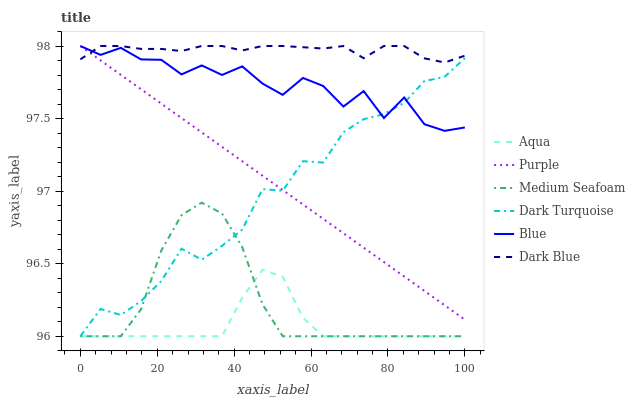Does Purple have the minimum area under the curve?
Answer yes or no. No. Does Purple have the maximum area under the curve?
Answer yes or no. No. Is Dark Turquoise the smoothest?
Answer yes or no. No. Is Dark Turquoise the roughest?
Answer yes or no. No. Does Purple have the lowest value?
Answer yes or no. No. Does Dark Turquoise have the highest value?
Answer yes or no. No. Is Medium Seafoam less than Blue?
Answer yes or no. Yes. Is Purple greater than Medium Seafoam?
Answer yes or no. Yes. Does Medium Seafoam intersect Blue?
Answer yes or no. No. 